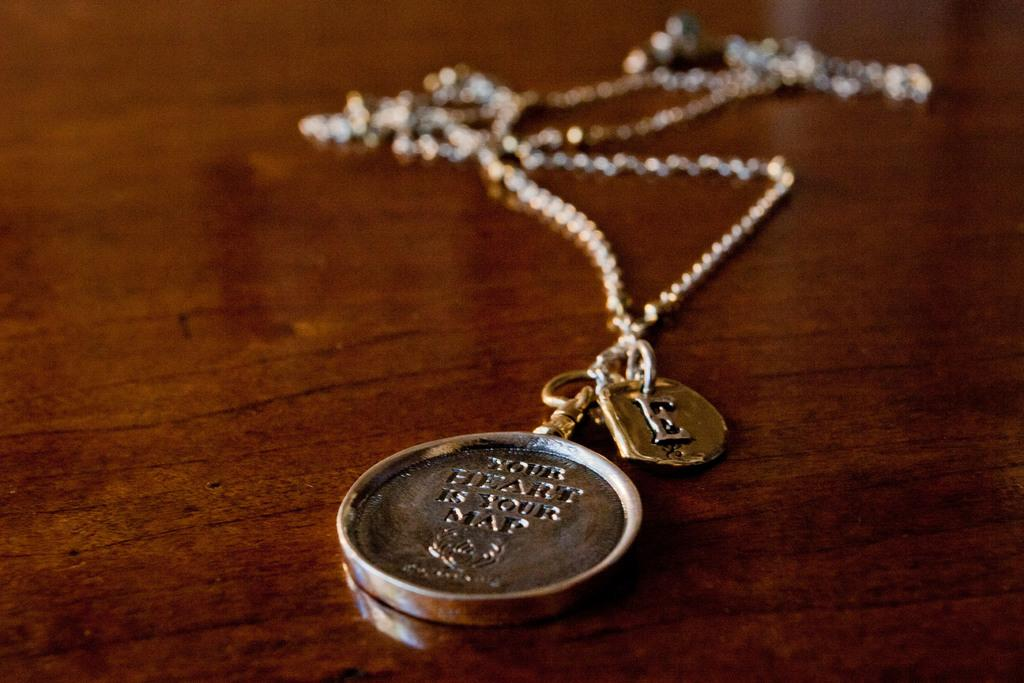<image>
Present a compact description of the photo's key features. A necklace that has the words your heart is your map engraved on it. 